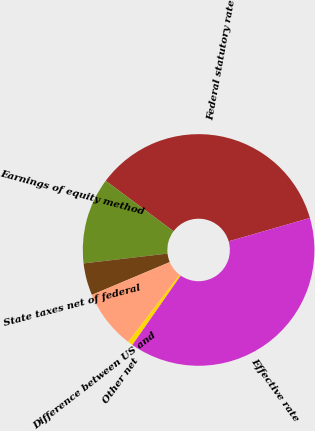Convert chart. <chart><loc_0><loc_0><loc_500><loc_500><pie_chart><fcel>Federal statutory rate<fcel>Earnings of equity method<fcel>State taxes net of federal<fcel>Difference between US and<fcel>Other net<fcel>Effective rate<nl><fcel>35.36%<fcel>12.04%<fcel>4.49%<fcel>8.26%<fcel>0.71%<fcel>39.14%<nl></chart> 